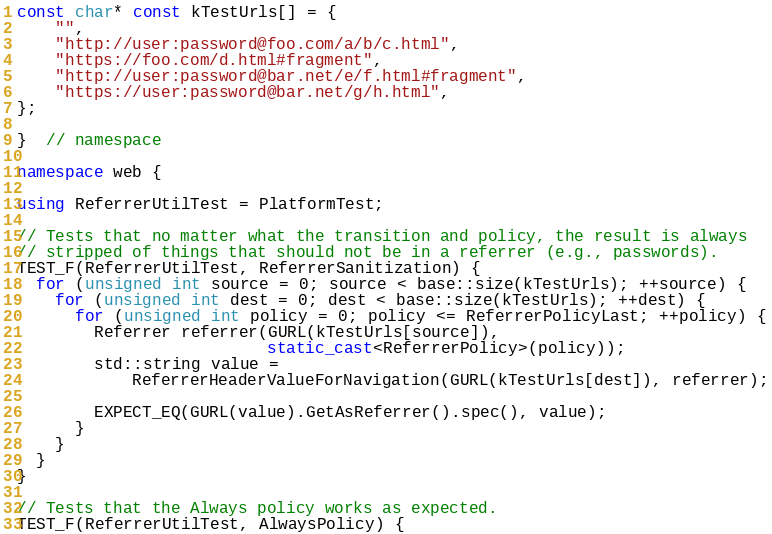<code> <loc_0><loc_0><loc_500><loc_500><_C++_>const char* const kTestUrls[] = {
    "",
    "http://user:password@foo.com/a/b/c.html",
    "https://foo.com/d.html#fragment",
    "http://user:password@bar.net/e/f.html#fragment",
    "https://user:password@bar.net/g/h.html",
};

}  // namespace

namespace web {

using ReferrerUtilTest = PlatformTest;

// Tests that no matter what the transition and policy, the result is always
// stripped of things that should not be in a referrer (e.g., passwords).
TEST_F(ReferrerUtilTest, ReferrerSanitization) {
  for (unsigned int source = 0; source < base::size(kTestUrls); ++source) {
    for (unsigned int dest = 0; dest < base::size(kTestUrls); ++dest) {
      for (unsigned int policy = 0; policy <= ReferrerPolicyLast; ++policy) {
        Referrer referrer(GURL(kTestUrls[source]),
                          static_cast<ReferrerPolicy>(policy));
        std::string value =
            ReferrerHeaderValueForNavigation(GURL(kTestUrls[dest]), referrer);

        EXPECT_EQ(GURL(value).GetAsReferrer().spec(), value);
      }
    }
  }
}

// Tests that the Always policy works as expected.
TEST_F(ReferrerUtilTest, AlwaysPolicy) {</code> 